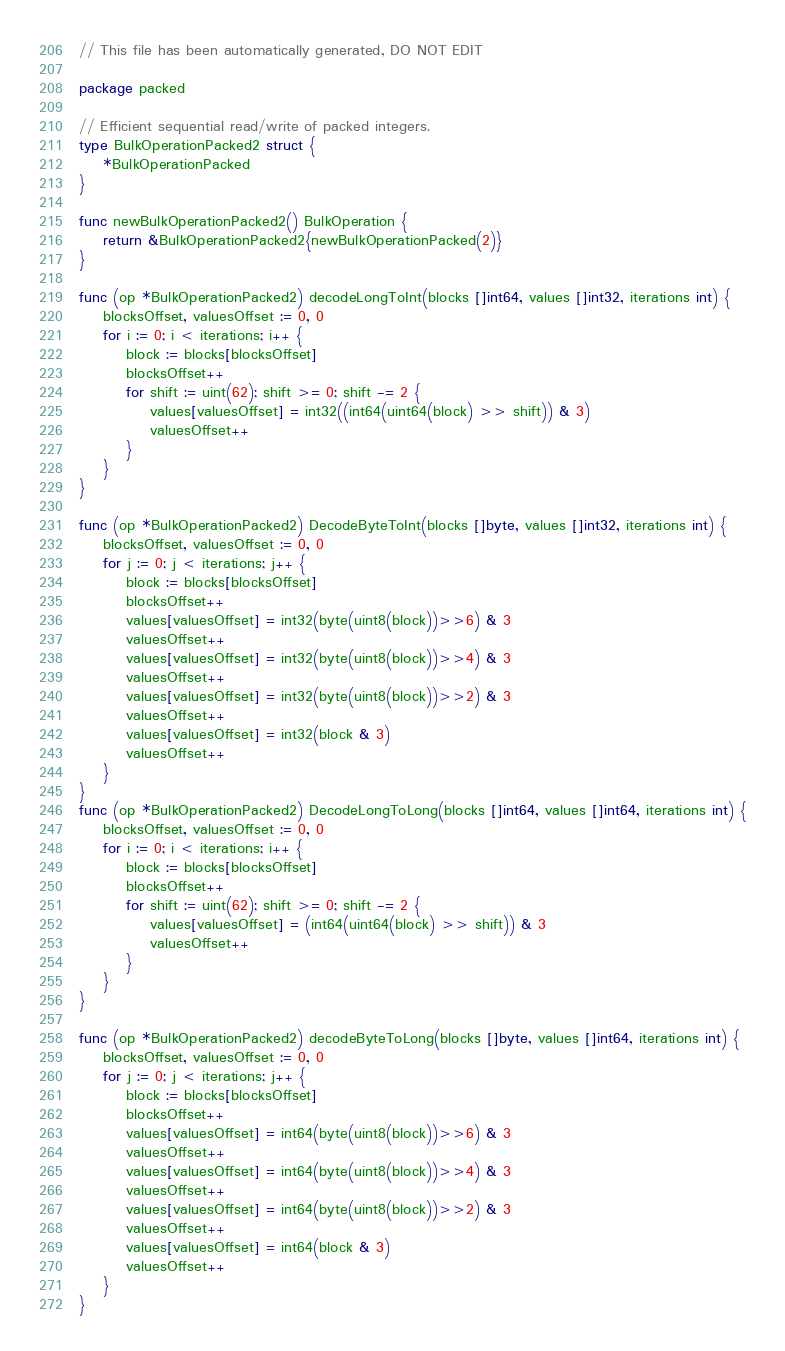Convert code to text. <code><loc_0><loc_0><loc_500><loc_500><_Go_>// This file has been automatically generated, DO NOT EDIT

package packed

// Efficient sequential read/write of packed integers.
type BulkOperationPacked2 struct {
	*BulkOperationPacked
}

func newBulkOperationPacked2() BulkOperation {
	return &BulkOperationPacked2{newBulkOperationPacked(2)}
}

func (op *BulkOperationPacked2) decodeLongToInt(blocks []int64, values []int32, iterations int) {
	blocksOffset, valuesOffset := 0, 0
	for i := 0; i < iterations; i++ {
		block := blocks[blocksOffset]
		blocksOffset++
		for shift := uint(62); shift >= 0; shift -= 2 {
			values[valuesOffset] = int32((int64(uint64(block) >> shift)) & 3)
			valuesOffset++
		}
	}
}

func (op *BulkOperationPacked2) DecodeByteToInt(blocks []byte, values []int32, iterations int) {
	blocksOffset, valuesOffset := 0, 0
	for j := 0; j < iterations; j++ {
		block := blocks[blocksOffset]
		blocksOffset++
		values[valuesOffset] = int32(byte(uint8(block))>>6) & 3
		valuesOffset++
		values[valuesOffset] = int32(byte(uint8(block))>>4) & 3
		valuesOffset++
		values[valuesOffset] = int32(byte(uint8(block))>>2) & 3
		valuesOffset++
		values[valuesOffset] = int32(block & 3)
		valuesOffset++
	}
}
func (op *BulkOperationPacked2) DecodeLongToLong(blocks []int64, values []int64, iterations int) {
	blocksOffset, valuesOffset := 0, 0
	for i := 0; i < iterations; i++ {
		block := blocks[blocksOffset]
		blocksOffset++
		for shift := uint(62); shift >= 0; shift -= 2 {
			values[valuesOffset] = (int64(uint64(block) >> shift)) & 3
			valuesOffset++
		}
	}
}

func (op *BulkOperationPacked2) decodeByteToLong(blocks []byte, values []int64, iterations int) {
	blocksOffset, valuesOffset := 0, 0
	for j := 0; j < iterations; j++ {
		block := blocks[blocksOffset]
		blocksOffset++
		values[valuesOffset] = int64(byte(uint8(block))>>6) & 3
		valuesOffset++
		values[valuesOffset] = int64(byte(uint8(block))>>4) & 3
		valuesOffset++
		values[valuesOffset] = int64(byte(uint8(block))>>2) & 3
		valuesOffset++
		values[valuesOffset] = int64(block & 3)
		valuesOffset++
	}
}
</code> 